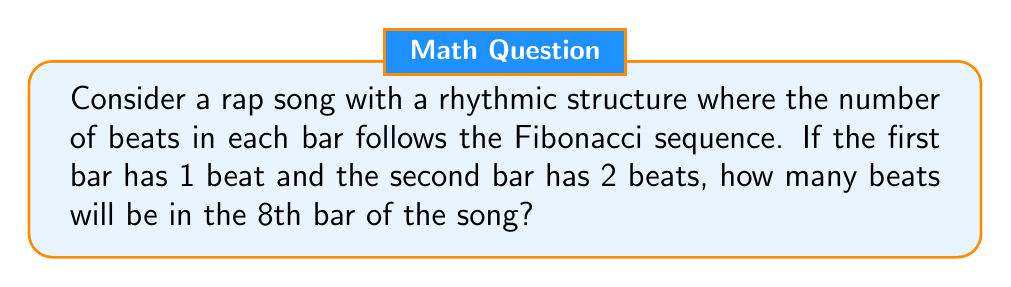Provide a solution to this math problem. To solve this problem, we need to understand the Fibonacci sequence and apply it to the rhythmic structure of the rap song. Let's break it down step-by-step:

1. The Fibonacci sequence is defined as follows:
   $F_n = F_{n-1} + F_{n-2}$ for $n > 2$
   With initial conditions: $F_1 = 1$ and $F_2 = 2$

2. Let's calculate the first 8 terms of the sequence:
   $F_1 = 1$ (given)
   $F_2 = 2$ (given)
   $F_3 = F_2 + F_1 = 2 + 1 = 3$
   $F_4 = F_3 + F_2 = 3 + 2 = 5$
   $F_5 = F_4 + F_3 = 5 + 3 = 8$
   $F_6 = F_5 + F_4 = 8 + 5 = 13$
   $F_7 = F_6 + F_5 = 13 + 8 = 21$
   $F_8 = F_7 + F_6 = 21 + 13 = 34$

3. In the context of the rap song:
   - The 1st bar has 1 beat
   - The 2nd bar has 2 beats
   - The 3rd bar has 3 beats
   - The 4th bar has 5 beats
   - The 5th bar has 8 beats
   - The 6th bar has 13 beats
   - The 7th bar has 21 beats
   - The 8th bar has 34 beats

Therefore, the 8th bar of the song will have 34 beats.
Answer: 34 beats 